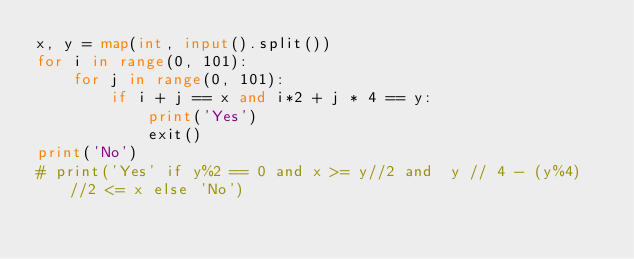Convert code to text. <code><loc_0><loc_0><loc_500><loc_500><_Python_>x, y = map(int, input().split())
for i in range(0, 101):
    for j in range(0, 101):
        if i + j == x and i*2 + j * 4 == y:
            print('Yes')
            exit()
print('No')
# print('Yes' if y%2 == 0 and x >= y//2 and  y // 4 - (y%4) //2 <= x else 'No')
</code> 